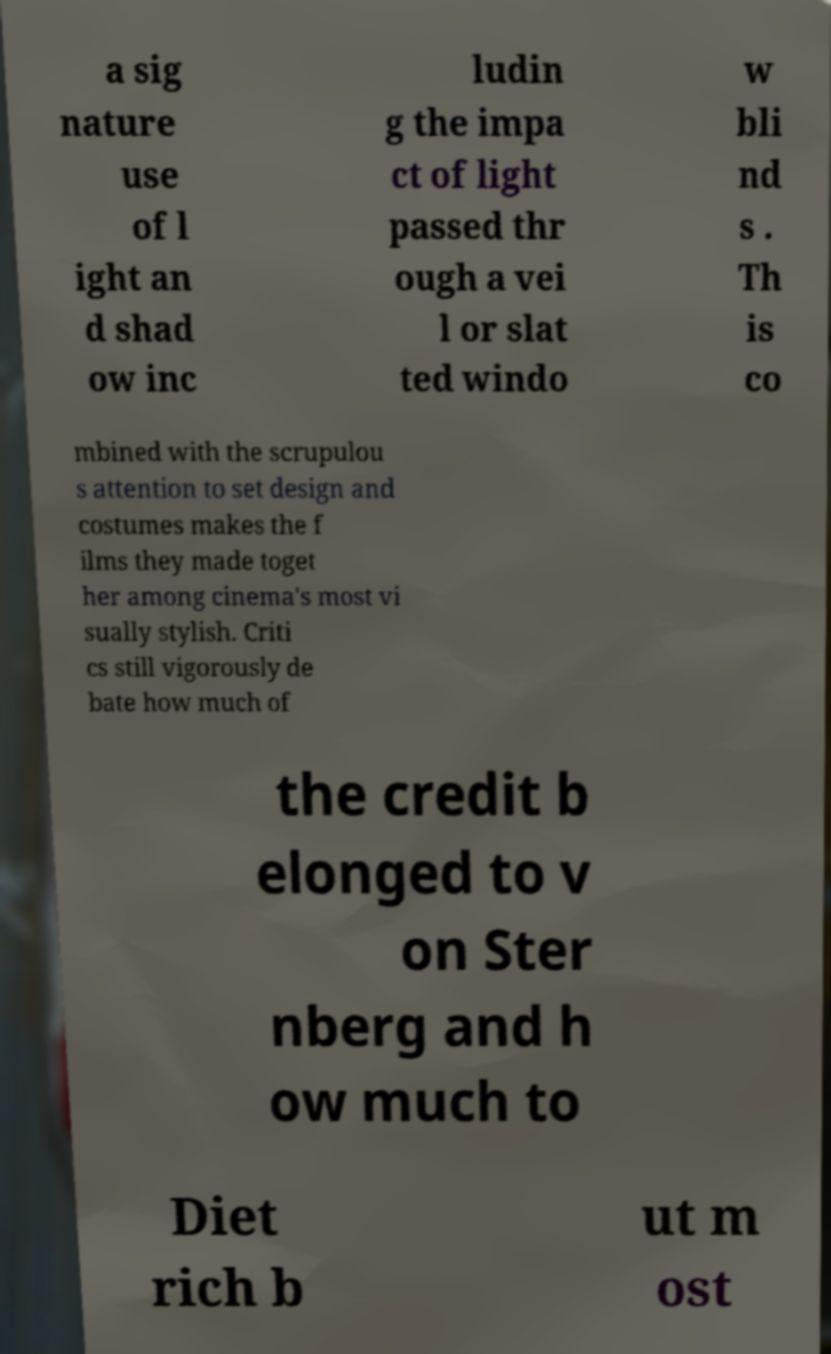Please identify and transcribe the text found in this image. a sig nature use of l ight an d shad ow inc ludin g the impa ct of light passed thr ough a vei l or slat ted windo w bli nd s . Th is co mbined with the scrupulou s attention to set design and costumes makes the f ilms they made toget her among cinema's most vi sually stylish. Criti cs still vigorously de bate how much of the credit b elonged to v on Ster nberg and h ow much to Diet rich b ut m ost 